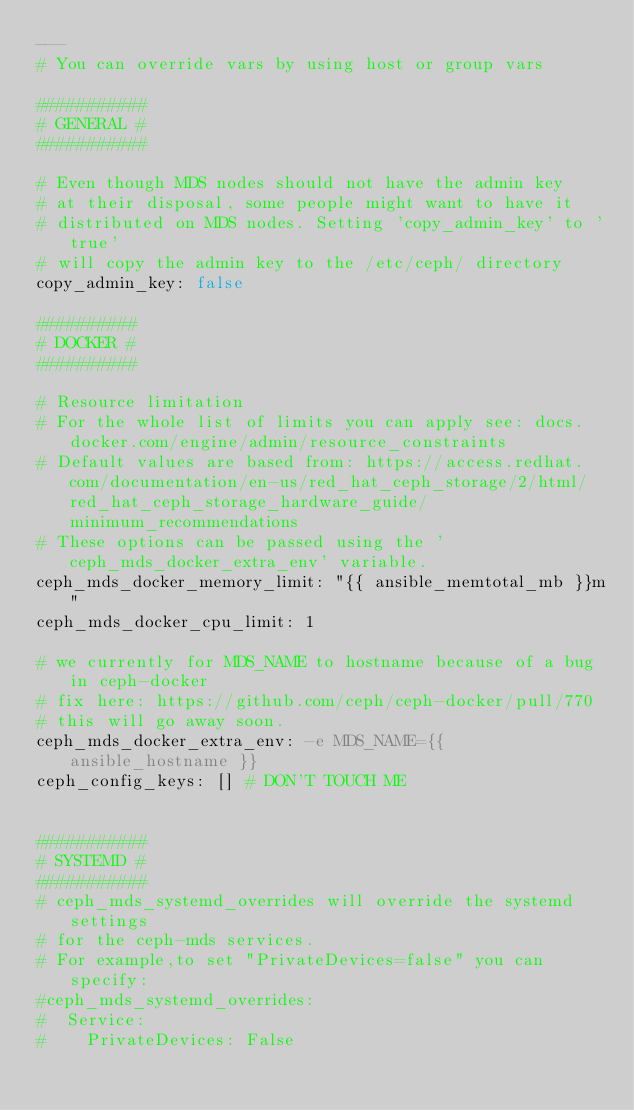<code> <loc_0><loc_0><loc_500><loc_500><_YAML_>---
# You can override vars by using host or group vars

###########
# GENERAL #
###########

# Even though MDS nodes should not have the admin key
# at their disposal, some people might want to have it
# distributed on MDS nodes. Setting 'copy_admin_key' to 'true'
# will copy the admin key to the /etc/ceph/ directory
copy_admin_key: false

##########
# DOCKER #
##########

# Resource limitation
# For the whole list of limits you can apply see: docs.docker.com/engine/admin/resource_constraints
# Default values are based from: https://access.redhat.com/documentation/en-us/red_hat_ceph_storage/2/html/red_hat_ceph_storage_hardware_guide/minimum_recommendations
# These options can be passed using the 'ceph_mds_docker_extra_env' variable.
ceph_mds_docker_memory_limit: "{{ ansible_memtotal_mb }}m"
ceph_mds_docker_cpu_limit: 1

# we currently for MDS_NAME to hostname because of a bug in ceph-docker
# fix here: https://github.com/ceph/ceph-docker/pull/770
# this will go away soon.
ceph_mds_docker_extra_env: -e MDS_NAME={{ ansible_hostname }}
ceph_config_keys: [] # DON'T TOUCH ME


###########
# SYSTEMD #
###########
# ceph_mds_systemd_overrides will override the systemd settings
# for the ceph-mds services.
# For example,to set "PrivateDevices=false" you can specify:
#ceph_mds_systemd_overrides:
#  Service:
#    PrivateDevices: False
</code> 